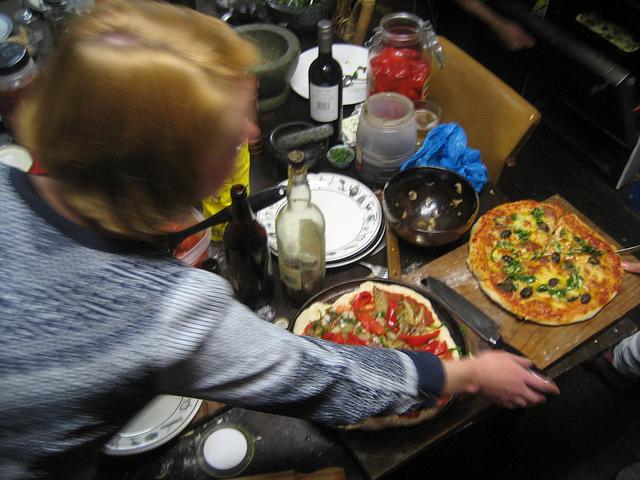How many pizzas are on the table?
Short answer required. 2. Where is the chefs knife?
Keep it brief. Between pizzas. What is the woman reaching for?
Be succinct. Knife. 